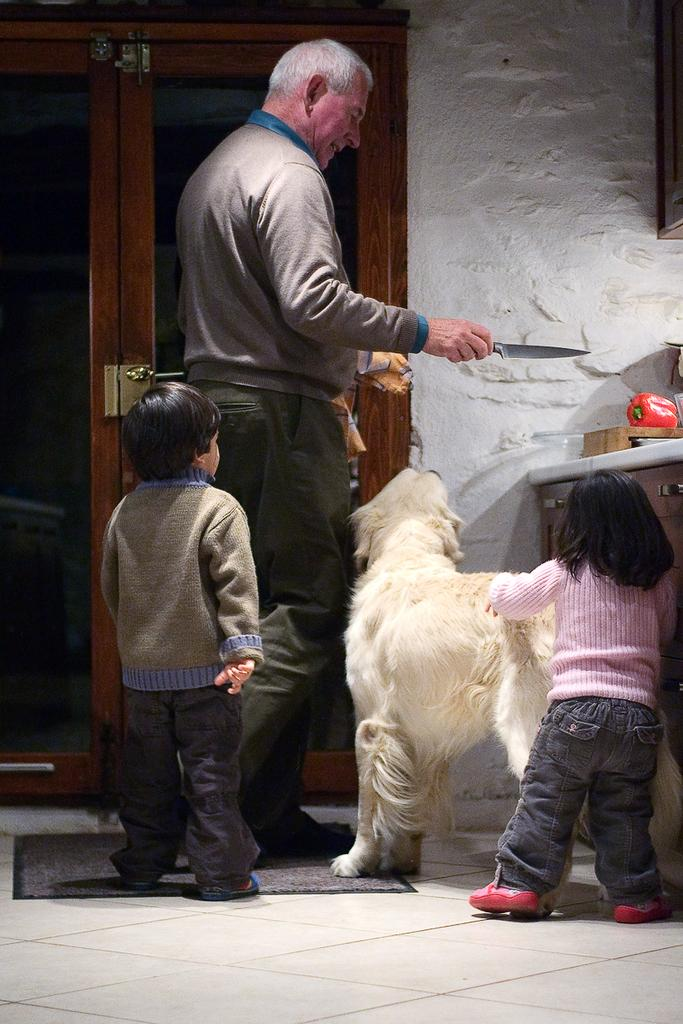What is the man in the image doing? The man is standing in the image and holding a knife. What is near the man in the image? There is a dog beside the man in the image. How many children are in the image? There are two little kids standing in the image. What can be seen in the background of the image? There is a door and a wall in the backdrop of the image. Who is the brother of the man in the image? There is no information about a brother in the image or the provided facts. --- Facts: 1. There is a car in the image. 2. The car is red. 3. The car has four wheels. 4. There is a road in the image. 5. The road is paved. Absurd Topics: ocean, birdhouse, guitar Conversation: What is the main subject of the image? The main subject of the image is a car. What color is the car? The car is red. How many wheels does the car have? The car has four wheels. What can be seen in the background of the image? There is a road in the image. What is the condition of the road? The road is paved. Reasoning: Let's think step by step in order to produce the conversation. We start by identifying the main subject in the image, which is the car. Then, we describe the car's color and the number of wheels it has. Next, we mention the background element, which is the road, and describe its condition. Each question is designed to elicit a specific detail about the image that is known from the provided facts. Absurd Question/Answer: Where is the birdhouse located in the image? There is no birdhouse present in the image. --- Facts: 1. There is a person sitting on a chair in the image. 2. The person is reading a book. 3. The book is open. 4. There is a table beside the chair. 5. There is a lamp on the table. Absurd Topics: elephant, rain, bicycle Conversation: What is the person in the image doing? The person is sitting on a chair in the image and reading a book. What is the condition of the book? The book is open. What is near the chair in the image? There is a table beside the chair. What is on the table in the image? There is a lamp on the table. Reasoning: Let's think step by step in order to produce the conversation. We start by identifying the main subject in the image, which is the person sitting on a chair. Then, we describe the person's activity, which is reading a book. Next, we 